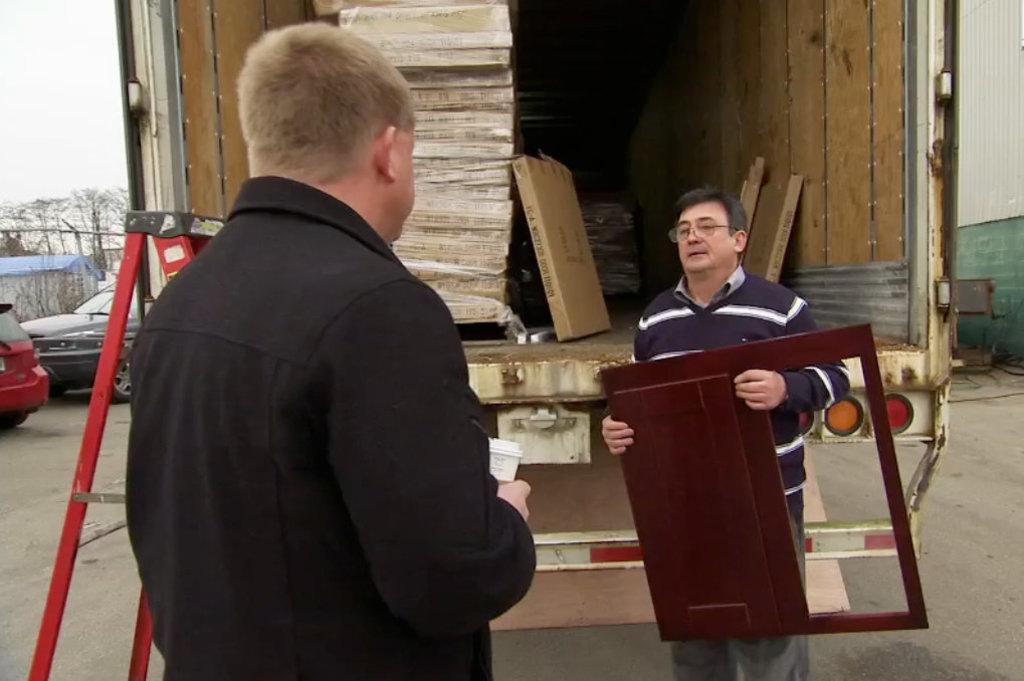Could you give a brief overview of what you see in this image? This is an outside view. Here I can see two men standing and looking at each other. The man who is on the right side is holding a wooden object in the hands. At the back of these people there is a truck. In the truck there are few boxes. On the left side there are two cars on the road and also I can see a house and trees. On the right side there is a shed. In the top left I can see the sky. 